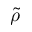Convert formula to latex. <formula><loc_0><loc_0><loc_500><loc_500>\tilde { \rho }</formula> 